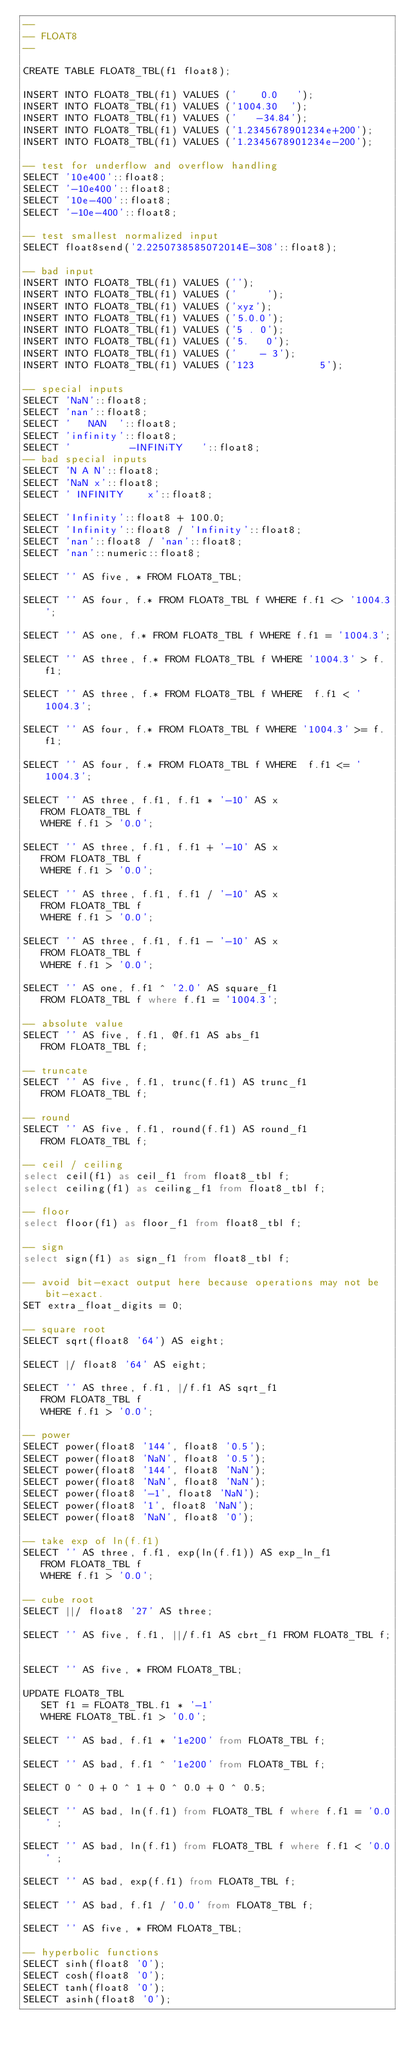Convert code to text. <code><loc_0><loc_0><loc_500><loc_500><_SQL_>--
-- FLOAT8
--

CREATE TABLE FLOAT8_TBL(f1 float8);

INSERT INTO FLOAT8_TBL(f1) VALUES ('    0.0   ');
INSERT INTO FLOAT8_TBL(f1) VALUES ('1004.30  ');
INSERT INTO FLOAT8_TBL(f1) VALUES ('   -34.84');
INSERT INTO FLOAT8_TBL(f1) VALUES ('1.2345678901234e+200');
INSERT INTO FLOAT8_TBL(f1) VALUES ('1.2345678901234e-200');

-- test for underflow and overflow handling
SELECT '10e400'::float8;
SELECT '-10e400'::float8;
SELECT '10e-400'::float8;
SELECT '-10e-400'::float8;

-- test smallest normalized input
SELECT float8send('2.2250738585072014E-308'::float8);

-- bad input
INSERT INTO FLOAT8_TBL(f1) VALUES ('');
INSERT INTO FLOAT8_TBL(f1) VALUES ('     ');
INSERT INTO FLOAT8_TBL(f1) VALUES ('xyz');
INSERT INTO FLOAT8_TBL(f1) VALUES ('5.0.0');
INSERT INTO FLOAT8_TBL(f1) VALUES ('5 . 0');
INSERT INTO FLOAT8_TBL(f1) VALUES ('5.   0');
INSERT INTO FLOAT8_TBL(f1) VALUES ('    - 3');
INSERT INTO FLOAT8_TBL(f1) VALUES ('123           5');

-- special inputs
SELECT 'NaN'::float8;
SELECT 'nan'::float8;
SELECT '   NAN  '::float8;
SELECT 'infinity'::float8;
SELECT '          -INFINiTY   '::float8;
-- bad special inputs
SELECT 'N A N'::float8;
SELECT 'NaN x'::float8;
SELECT ' INFINITY    x'::float8;

SELECT 'Infinity'::float8 + 100.0;
SELECT 'Infinity'::float8 / 'Infinity'::float8;
SELECT 'nan'::float8 / 'nan'::float8;
SELECT 'nan'::numeric::float8;

SELECT '' AS five, * FROM FLOAT8_TBL;

SELECT '' AS four, f.* FROM FLOAT8_TBL f WHERE f.f1 <> '1004.3';

SELECT '' AS one, f.* FROM FLOAT8_TBL f WHERE f.f1 = '1004.3';

SELECT '' AS three, f.* FROM FLOAT8_TBL f WHERE '1004.3' > f.f1;

SELECT '' AS three, f.* FROM FLOAT8_TBL f WHERE  f.f1 < '1004.3';

SELECT '' AS four, f.* FROM FLOAT8_TBL f WHERE '1004.3' >= f.f1;

SELECT '' AS four, f.* FROM FLOAT8_TBL f WHERE  f.f1 <= '1004.3';

SELECT '' AS three, f.f1, f.f1 * '-10' AS x
   FROM FLOAT8_TBL f
   WHERE f.f1 > '0.0';

SELECT '' AS three, f.f1, f.f1 + '-10' AS x
   FROM FLOAT8_TBL f
   WHERE f.f1 > '0.0';

SELECT '' AS three, f.f1, f.f1 / '-10' AS x
   FROM FLOAT8_TBL f
   WHERE f.f1 > '0.0';

SELECT '' AS three, f.f1, f.f1 - '-10' AS x
   FROM FLOAT8_TBL f
   WHERE f.f1 > '0.0';

SELECT '' AS one, f.f1 ^ '2.0' AS square_f1
   FROM FLOAT8_TBL f where f.f1 = '1004.3';

-- absolute value
SELECT '' AS five, f.f1, @f.f1 AS abs_f1
   FROM FLOAT8_TBL f;

-- truncate
SELECT '' AS five, f.f1, trunc(f.f1) AS trunc_f1
   FROM FLOAT8_TBL f;

-- round
SELECT '' AS five, f.f1, round(f.f1) AS round_f1
   FROM FLOAT8_TBL f;

-- ceil / ceiling
select ceil(f1) as ceil_f1 from float8_tbl f;
select ceiling(f1) as ceiling_f1 from float8_tbl f;

-- floor
select floor(f1) as floor_f1 from float8_tbl f;

-- sign
select sign(f1) as sign_f1 from float8_tbl f;

-- avoid bit-exact output here because operations may not be bit-exact.
SET extra_float_digits = 0;

-- square root
SELECT sqrt(float8 '64') AS eight;

SELECT |/ float8 '64' AS eight;

SELECT '' AS three, f.f1, |/f.f1 AS sqrt_f1
   FROM FLOAT8_TBL f
   WHERE f.f1 > '0.0';

-- power
SELECT power(float8 '144', float8 '0.5');
SELECT power(float8 'NaN', float8 '0.5');
SELECT power(float8 '144', float8 'NaN');
SELECT power(float8 'NaN', float8 'NaN');
SELECT power(float8 '-1', float8 'NaN');
SELECT power(float8 '1', float8 'NaN');
SELECT power(float8 'NaN', float8 '0');

-- take exp of ln(f.f1)
SELECT '' AS three, f.f1, exp(ln(f.f1)) AS exp_ln_f1
   FROM FLOAT8_TBL f
   WHERE f.f1 > '0.0';

-- cube root
SELECT ||/ float8 '27' AS three;

SELECT '' AS five, f.f1, ||/f.f1 AS cbrt_f1 FROM FLOAT8_TBL f;


SELECT '' AS five, * FROM FLOAT8_TBL;

UPDATE FLOAT8_TBL
   SET f1 = FLOAT8_TBL.f1 * '-1'
   WHERE FLOAT8_TBL.f1 > '0.0';

SELECT '' AS bad, f.f1 * '1e200' from FLOAT8_TBL f;

SELECT '' AS bad, f.f1 ^ '1e200' from FLOAT8_TBL f;

SELECT 0 ^ 0 + 0 ^ 1 + 0 ^ 0.0 + 0 ^ 0.5;

SELECT '' AS bad, ln(f.f1) from FLOAT8_TBL f where f.f1 = '0.0' ;

SELECT '' AS bad, ln(f.f1) from FLOAT8_TBL f where f.f1 < '0.0' ;

SELECT '' AS bad, exp(f.f1) from FLOAT8_TBL f;

SELECT '' AS bad, f.f1 / '0.0' from FLOAT8_TBL f;

SELECT '' AS five, * FROM FLOAT8_TBL;

-- hyperbolic functions
SELECT sinh(float8 '0');
SELECT cosh(float8 '0');
SELECT tanh(float8 '0');
SELECT asinh(float8 '0');</code> 